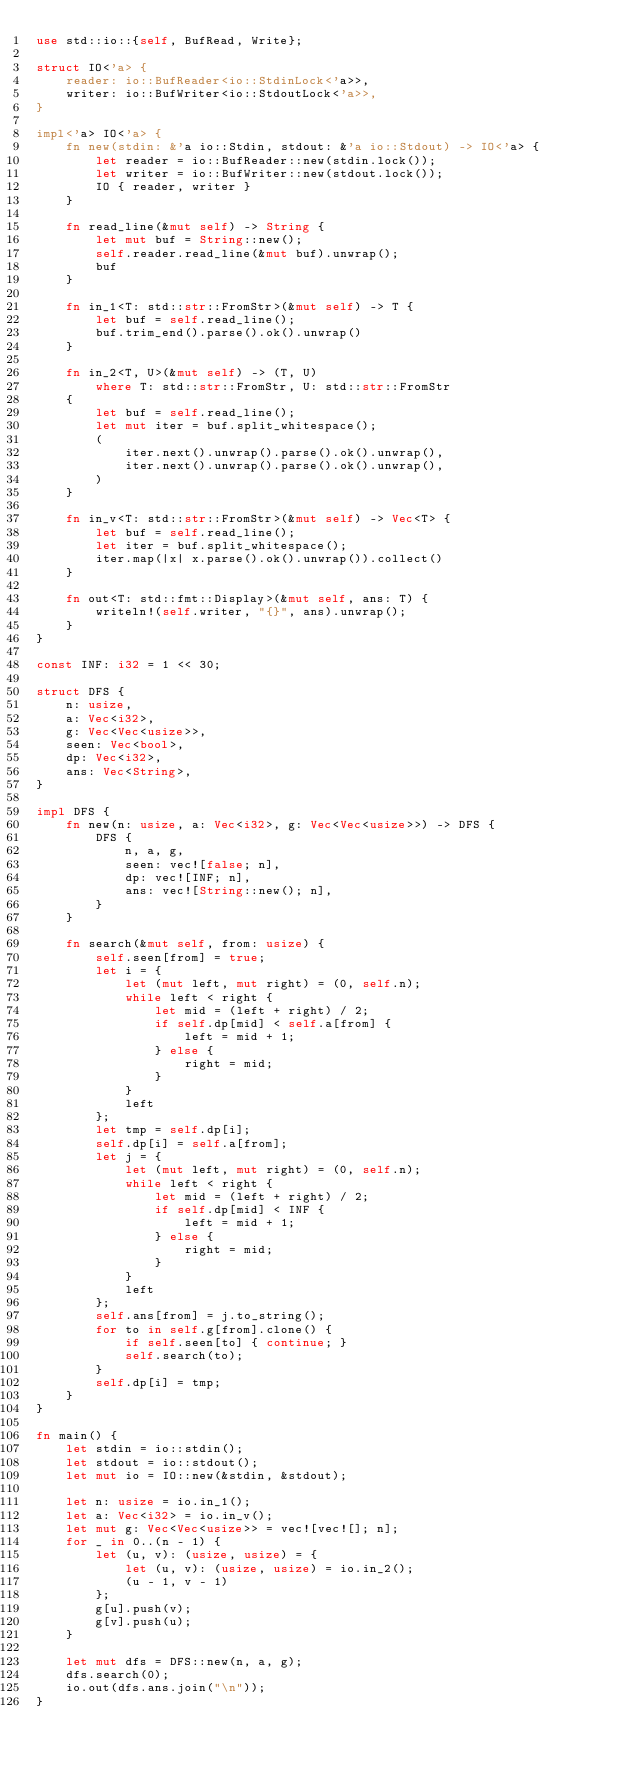<code> <loc_0><loc_0><loc_500><loc_500><_Rust_>use std::io::{self, BufRead, Write};

struct IO<'a> {
    reader: io::BufReader<io::StdinLock<'a>>,
    writer: io::BufWriter<io::StdoutLock<'a>>,
}

impl<'a> IO<'a> {
    fn new(stdin: &'a io::Stdin, stdout: &'a io::Stdout) -> IO<'a> {
        let reader = io::BufReader::new(stdin.lock());
        let writer = io::BufWriter::new(stdout.lock());
        IO { reader, writer }
    }

    fn read_line(&mut self) -> String {
        let mut buf = String::new();
        self.reader.read_line(&mut buf).unwrap();
        buf
    }

    fn in_1<T: std::str::FromStr>(&mut self) -> T {
        let buf = self.read_line();
        buf.trim_end().parse().ok().unwrap()
    }

    fn in_2<T, U>(&mut self) -> (T, U)
        where T: std::str::FromStr, U: std::str::FromStr
    {
        let buf = self.read_line();
        let mut iter = buf.split_whitespace();
        (
            iter.next().unwrap().parse().ok().unwrap(),
            iter.next().unwrap().parse().ok().unwrap(),
        )
    }

    fn in_v<T: std::str::FromStr>(&mut self) -> Vec<T> {
        let buf = self.read_line();
        let iter = buf.split_whitespace();
        iter.map(|x| x.parse().ok().unwrap()).collect()
    }

    fn out<T: std::fmt::Display>(&mut self, ans: T) {
        writeln!(self.writer, "{}", ans).unwrap();
    }
}

const INF: i32 = 1 << 30;

struct DFS {
    n: usize,
    a: Vec<i32>,
    g: Vec<Vec<usize>>,
    seen: Vec<bool>,
    dp: Vec<i32>,
    ans: Vec<String>,
}

impl DFS {
    fn new(n: usize, a: Vec<i32>, g: Vec<Vec<usize>>) -> DFS {
        DFS {
            n, a, g,
            seen: vec![false; n],
            dp: vec![INF; n],
            ans: vec![String::new(); n],
        }
    }

    fn search(&mut self, from: usize) {
        self.seen[from] = true;
        let i = {
            let (mut left, mut right) = (0, self.n);
            while left < right {
                let mid = (left + right) / 2;
                if self.dp[mid] < self.a[from] {
                    left = mid + 1;
                } else {
                    right = mid;
                }
            }
            left
        };
        let tmp = self.dp[i];
        self.dp[i] = self.a[from];
        let j = {
            let (mut left, mut right) = (0, self.n);
            while left < right {
                let mid = (left + right) / 2;
                if self.dp[mid] < INF {
                    left = mid + 1;
                } else {
                    right = mid;
                }
            }
            left
        };
        self.ans[from] = j.to_string();
        for to in self.g[from].clone() {
            if self.seen[to] { continue; }
            self.search(to);
        }
        self.dp[i] = tmp;
    }
}

fn main() {
    let stdin = io::stdin();
    let stdout = io::stdout();
    let mut io = IO::new(&stdin, &stdout);

    let n: usize = io.in_1();
    let a: Vec<i32> = io.in_v();
    let mut g: Vec<Vec<usize>> = vec![vec![]; n];
    for _ in 0..(n - 1) {
        let (u, v): (usize, usize) = {
            let (u, v): (usize, usize) = io.in_2();
            (u - 1, v - 1)
        };
        g[u].push(v);
        g[v].push(u);
    }

    let mut dfs = DFS::new(n, a, g);
    dfs.search(0);
    io.out(dfs.ans.join("\n"));
}</code> 